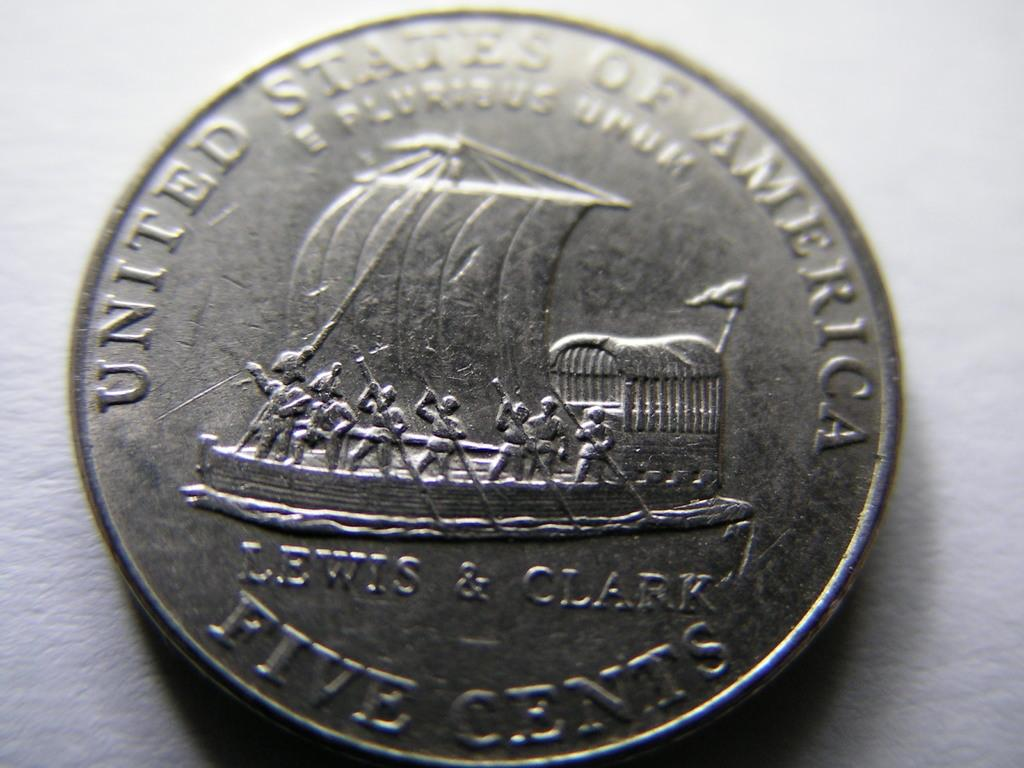<image>
Create a compact narrative representing the image presented. a United States of America Five Cents coin 